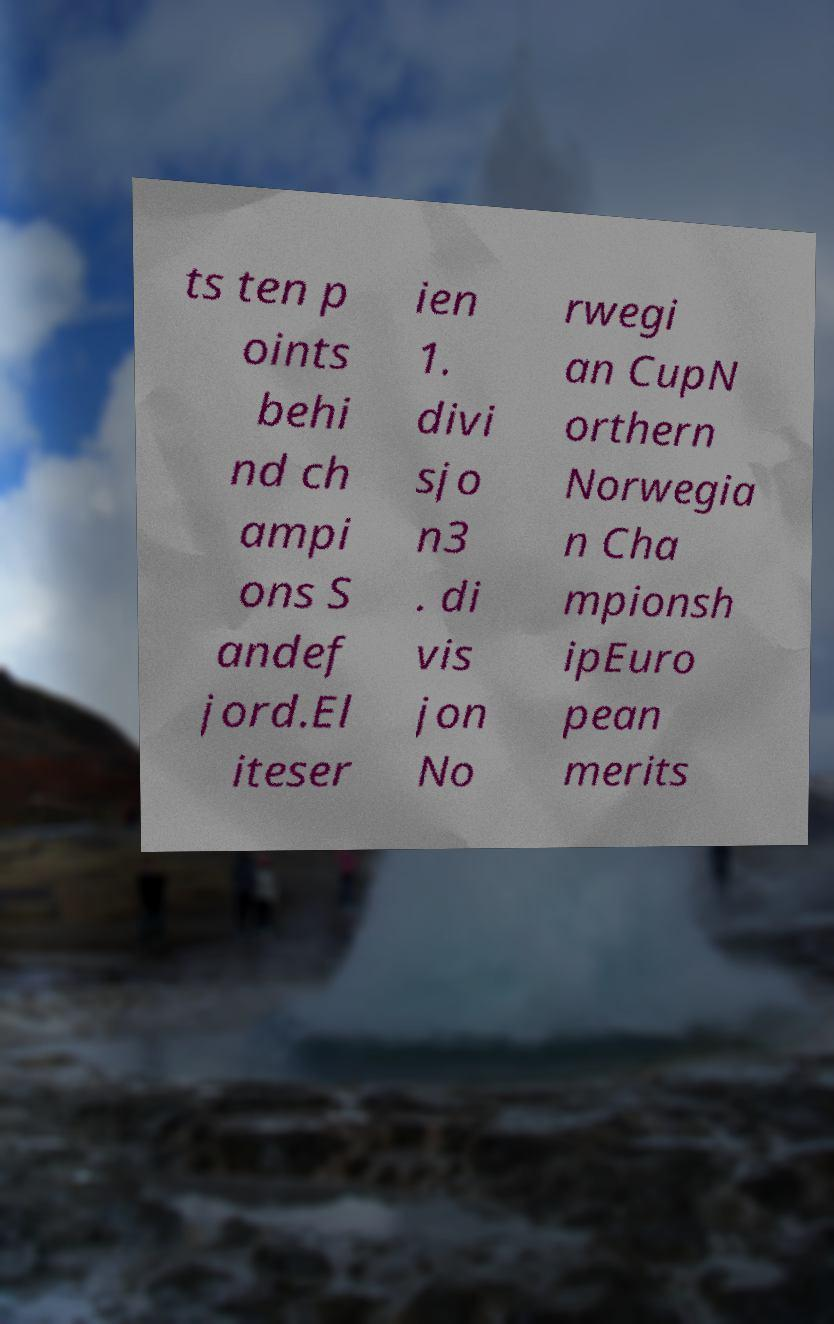Can you accurately transcribe the text from the provided image for me? ts ten p oints behi nd ch ampi ons S andef jord.El iteser ien 1. divi sjo n3 . di vis jon No rwegi an CupN orthern Norwegia n Cha mpionsh ipEuro pean merits 